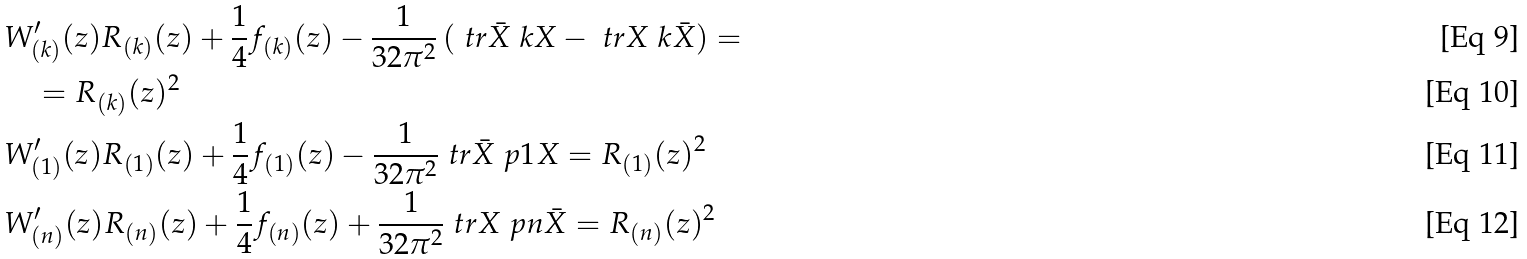<formula> <loc_0><loc_0><loc_500><loc_500>& { W } ^ { \prime } _ { ( k ) } ( z ) R _ { ( k ) } ( z ) + \frac { 1 } { 4 } f _ { ( k ) } ( z ) - \frac { 1 } { 3 2 \pi ^ { 2 } } \left ( \ t r \bar { X } \ k X - \ t r X \ k \bar { X } \right ) = \\ & \quad = R _ { ( k ) } ( z ) ^ { 2 } \\ & { W } ^ { \prime } _ { ( 1 ) } ( z ) R _ { ( 1 ) } ( z ) + \frac { 1 } { 4 } f _ { ( 1 ) } ( z ) - \frac { 1 } { 3 2 \pi ^ { 2 } } \ t r \bar { X } \ p 1 X = R _ { ( 1 ) } ( z ) ^ { 2 } \\ & { W } ^ { \prime } _ { ( n ) } ( z ) R _ { ( n ) } ( z ) + \frac { 1 } { 4 } f _ { ( n ) } ( z ) + \frac { 1 } { 3 2 \pi ^ { 2 } } \ t r X \ p n \bar { X } = R _ { ( n ) } ( z ) ^ { 2 }</formula> 